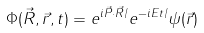<formula> <loc_0><loc_0><loc_500><loc_500>\Phi ( \vec { R } , \vec { r } , t ) = e ^ { i \vec { P } \cdot \vec { R } / } e ^ { - i E t / } \psi ( \vec { r } )</formula> 